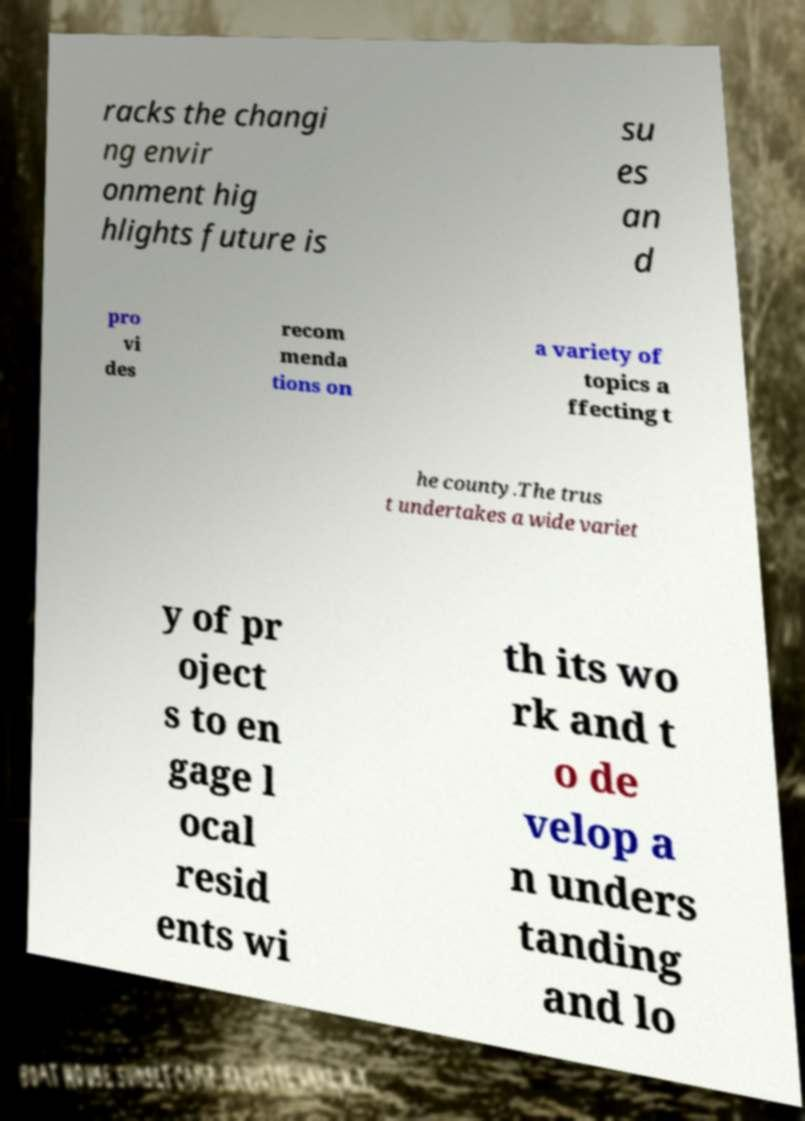Can you read and provide the text displayed in the image?This photo seems to have some interesting text. Can you extract and type it out for me? racks the changi ng envir onment hig hlights future is su es an d pro vi des recom menda tions on a variety of topics a ffecting t he county.The trus t undertakes a wide variet y of pr oject s to en gage l ocal resid ents wi th its wo rk and t o de velop a n unders tanding and lo 